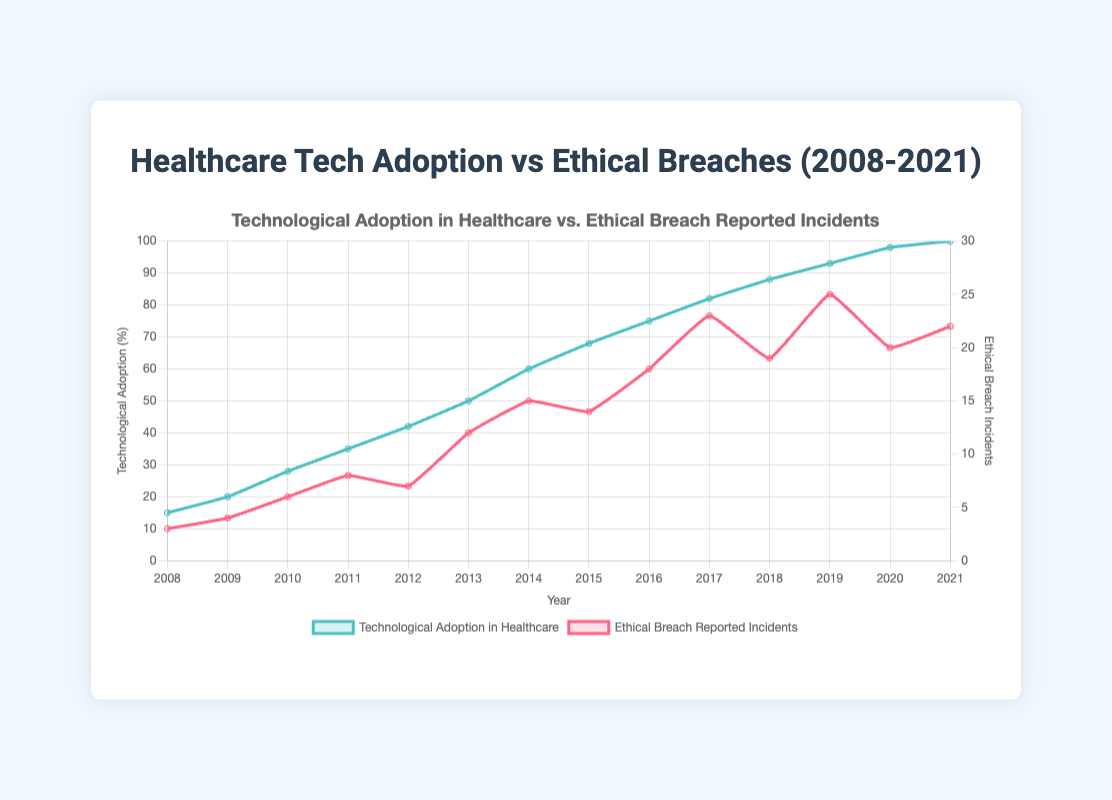What trend can be observed in technological adoption in healthcare from 2008 to 2021? Technological adoption in healthcare shows a steady increase from 15% in 2008 to 100% in 2021. This can be observed from the upward trend of the green line representing technological adoption in the figure.
Answer: It steadily increased How did the number of ethical breach incidents change between 2013 and 2014? The number of ethical breach incidents increased from 12 in 2013 to 15 in 2014. This is seen as an upward movement of the red line on the graph between these years.
Answer: It increased What year had the highest number of ethical breach reported incidents and what was the value? The year with the highest number of ethical breach reported incidents is 2019 with 25 incidents. This can be deduced from finding the highest point on the red line representing ethical breach incidents.
Answer: 2019 with 25 incidents Compare the increase in technological adoption between 2010 and 2011 with the increase between 2011 and 2012. Which one showed a greater increase? From 2010 to 2011, technological adoption increased from 28% to 35%, a difference of 7%. From 2011 to 2012, it increased from 35% to 42%, a difference of 7%. Both periods show an equal increase of 7%.
Answer: Both increases are equal What is the general trend in the relationship between technological adoption and ethical breach incidents from 2008 to 2021? As technological adoption increased, the number of ethical breach incidents also showed an increasing trend, though not always at a consistent rate. This is indicated by the simultaneous upward trend of both lines over the years.
Answer: Both increased In which year did technological adoption in healthcare see the largest one-year increase, and by how much did it increase? The largest one-year increase in technological adoption occurred between 2013 and 2014, increasing from 50% to 60%. This is an increase of 10%, which is the largest jump observed in the trend lines.
Answer: 2013 to 2014, by 10% How many years saw a decrease in the number of ethical breach reported incidents compared to the previous year? There are two years where the ethical breach incidents decreased compared to the previous year: 2012 (7 incidents, down from 8 in 2011) and 2018 (19 incidents, down from 23 in 2017).
Answer: 2 years What is the average number of ethical breach incidents reported per year from 2008 to 2021? Summing the number of incidents from 2008 to 2021: 3+4+6+8+7+12+15+14+18+23+19+25+20+22 = 196. There are 14 years, so the average is 196/14 = 14.
Answer: 14 Which year had the highest relative increase in ethical breach incidents compared to the previous year, and what was the percentage increase? The highest relative increase occurred between 2012 and 2013. The number increased from 7 incidents to 12 incidents. The relative increase is ((12-7)/7) * 100% = 71.4%.
Answer: 2013, 71.4% What is the difference in technological adoption between 2008 and 2021? Technological adoption increased from 15% in 2008 to 100% in 2021. The difference is 100% - 15% = 85%.
Answer: 85% 